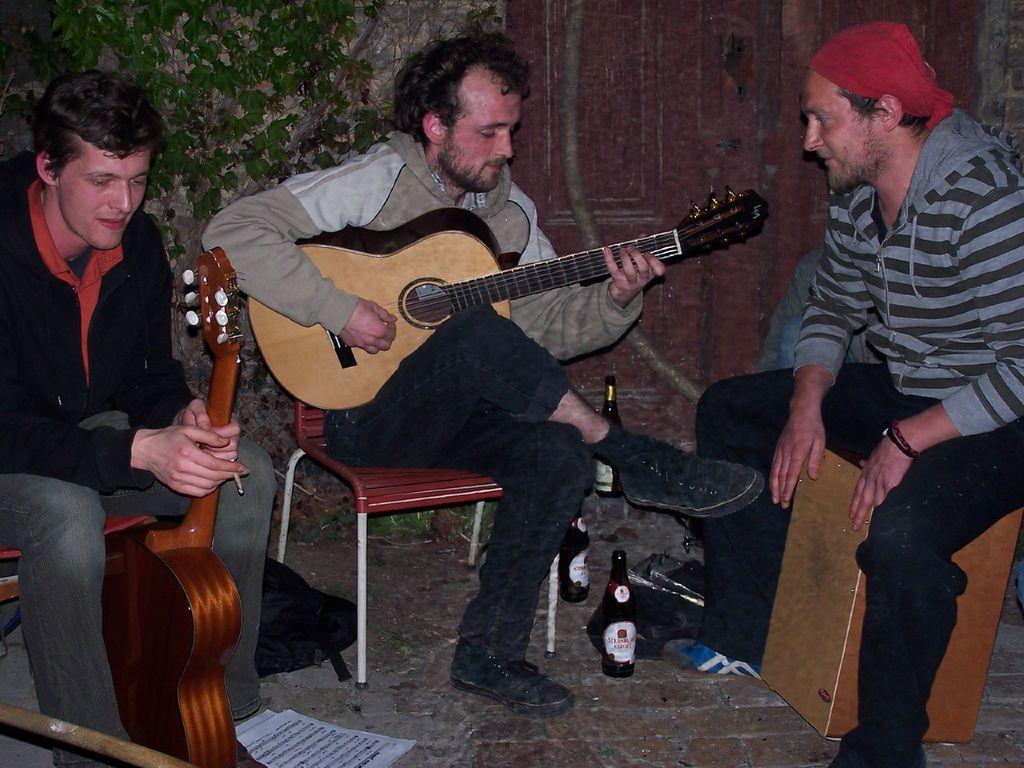Describe this image in one or two sentences. In this image I can see three men are sitting on the chairs. One is holding the guitar and one is playing the guitar. On the floor I can see a bag, two bottles and few papers. In the background I can see a wall and a creeper plant. 